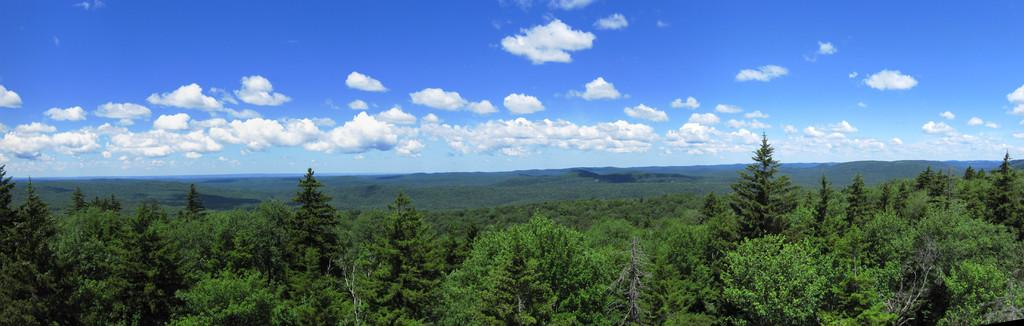What can be seen at the top of the image? The sky is visible towards the top of the image. What is present in the sky? There are clouds in the sky. What type of vegetation is visible towards the bottom of the image? Trees are present towards the bottom of the image. What type of work is the servant doing in the image? There is no servant present in the image, so it is not possible to answer that question. What did the people have for breakfast in the image? There is no reference to breakfast or any food in the image, so it cannot be determined what, if anything, was consumed for breakfast. 